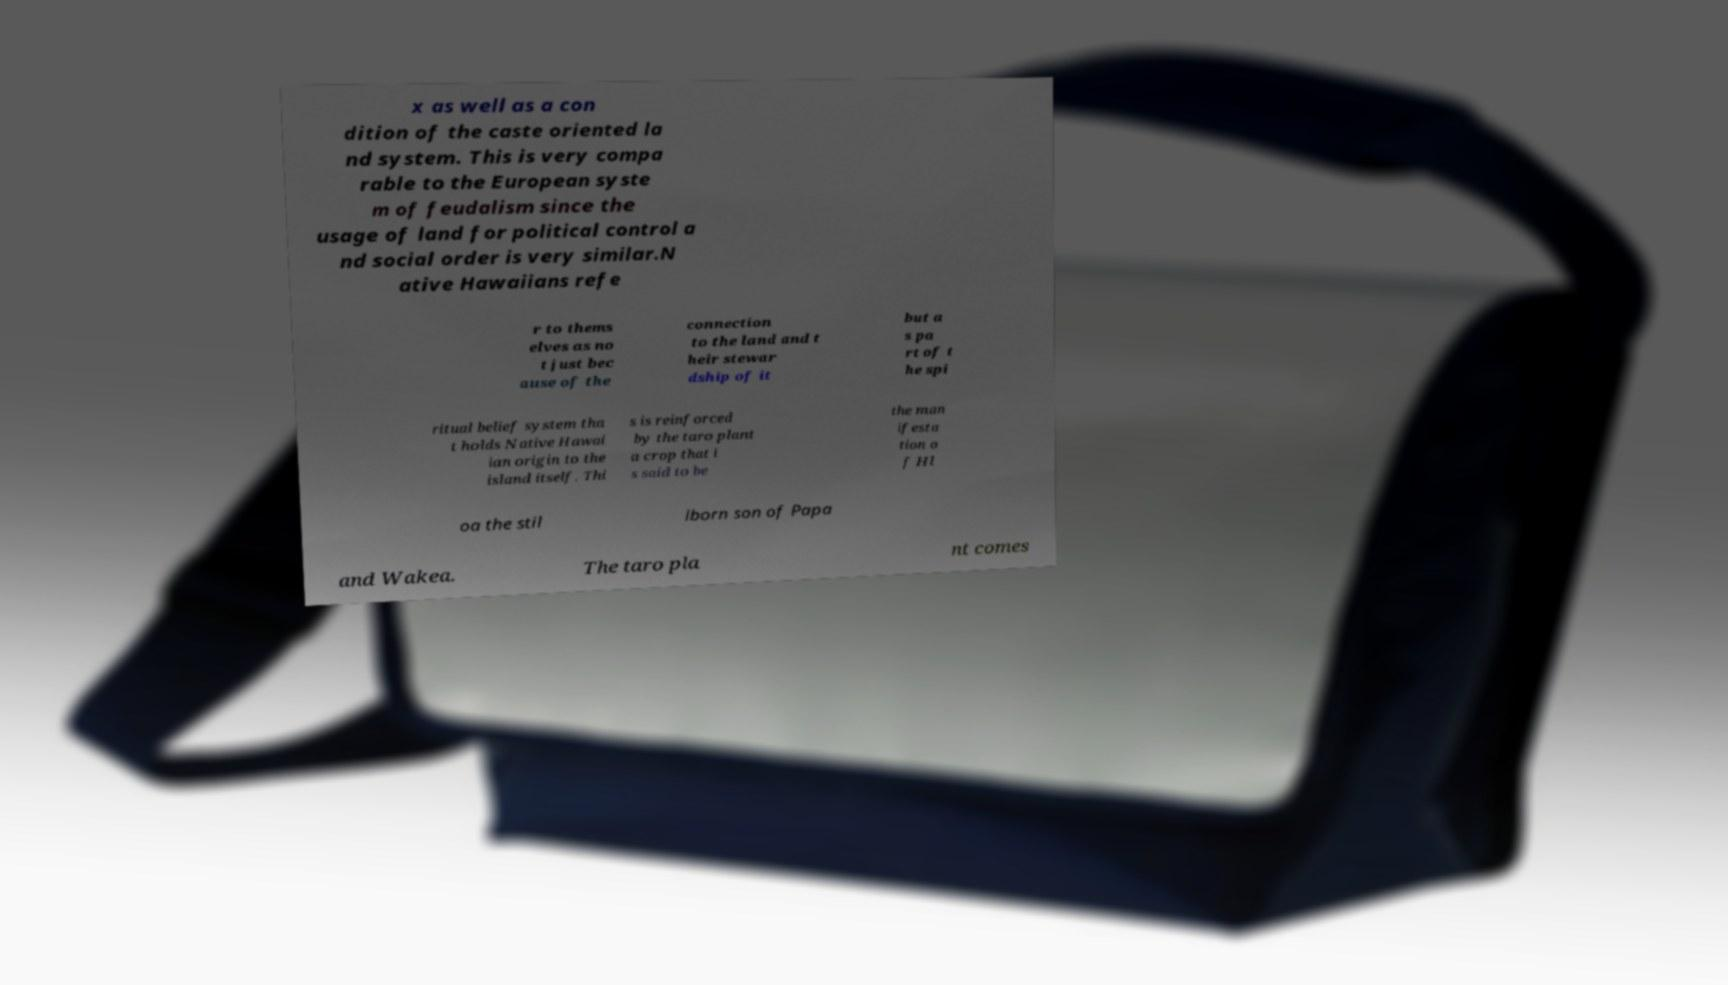Could you assist in decoding the text presented in this image and type it out clearly? x as well as a con dition of the caste oriented la nd system. This is very compa rable to the European syste m of feudalism since the usage of land for political control a nd social order is very similar.N ative Hawaiians refe r to thems elves as no t just bec ause of the connection to the land and t heir stewar dship of it but a s pa rt of t he spi ritual belief system tha t holds Native Hawai ian origin to the island itself. Thi s is reinforced by the taro plant a crop that i s said to be the man ifesta tion o f Hl oa the stil lborn son of Papa and Wakea. The taro pla nt comes 